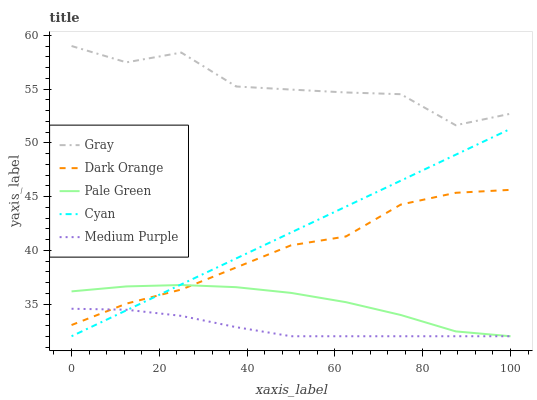Does Cyan have the minimum area under the curve?
Answer yes or no. No. Does Cyan have the maximum area under the curve?
Answer yes or no. No. Is Gray the smoothest?
Answer yes or no. No. Is Cyan the roughest?
Answer yes or no. No. Does Gray have the lowest value?
Answer yes or no. No. Does Cyan have the highest value?
Answer yes or no. No. Is Cyan less than Gray?
Answer yes or no. Yes. Is Gray greater than Dark Orange?
Answer yes or no. Yes. Does Cyan intersect Gray?
Answer yes or no. No. 